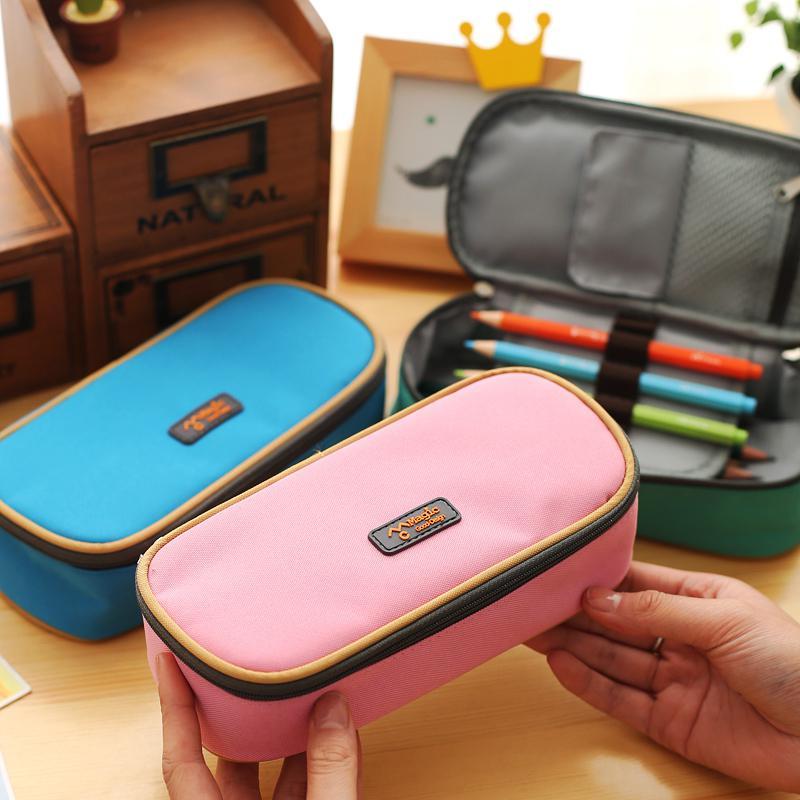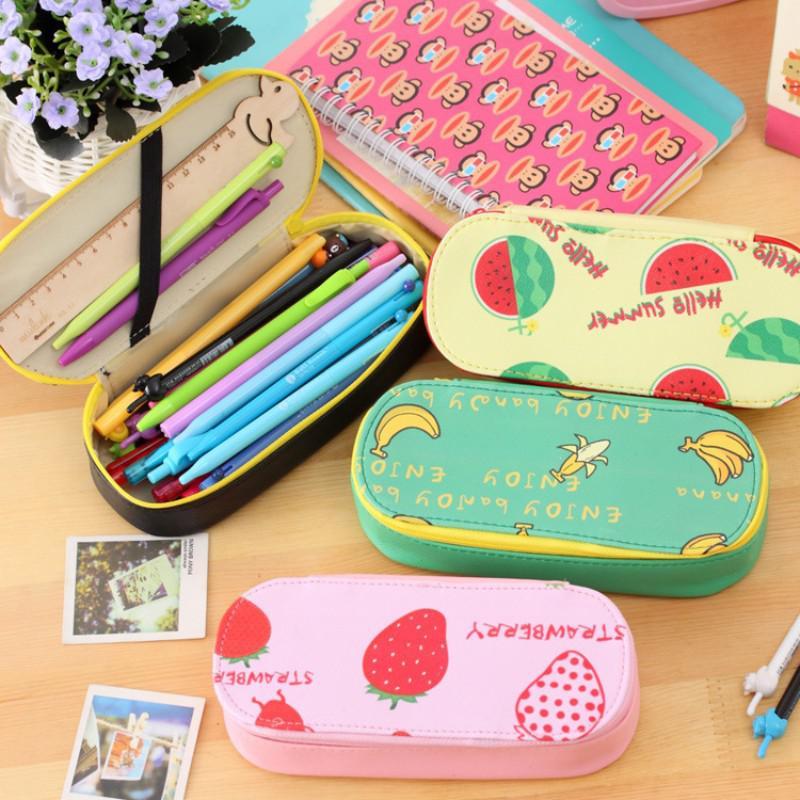The first image is the image on the left, the second image is the image on the right. Given the left and right images, does the statement "The open pouch in one of the images contains an electronic device." hold true? Answer yes or no. No. 